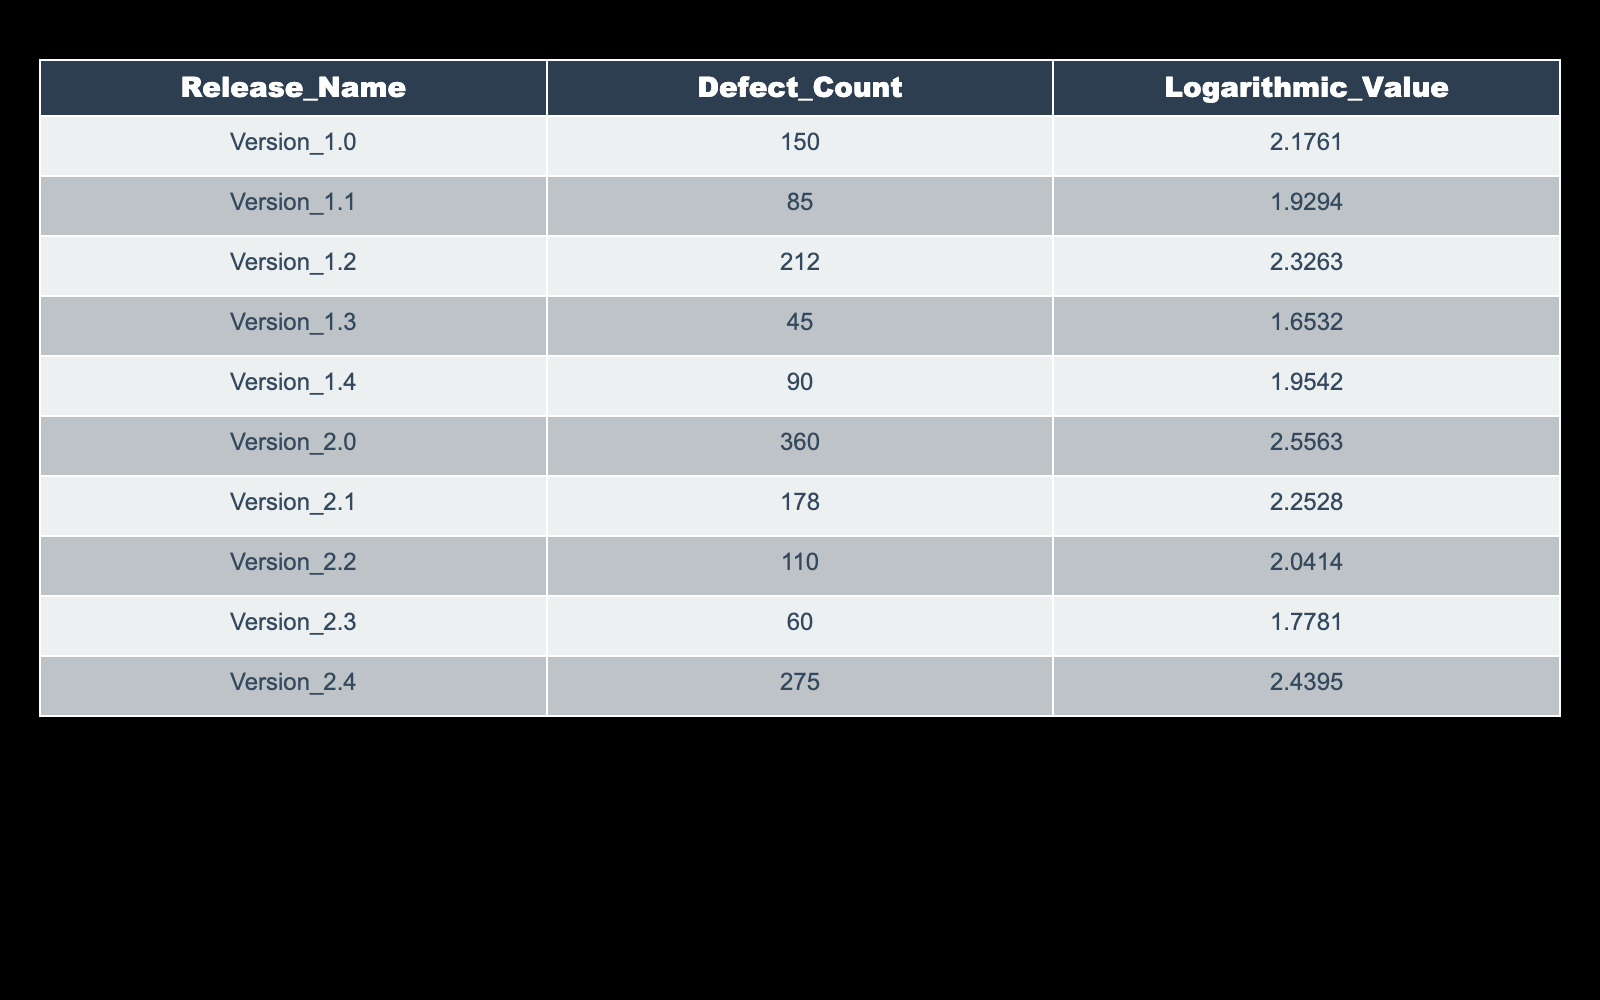What is the defect count for Version 1.1? From the table, we can look at the row corresponding to Version 1.1 and see under the Defect Count column that the value is 85.
Answer: 85 Which release has the highest logarithmic value? To find the highest logarithmic value, we compare the Logarithmic Value column and identify that Version 2.0 has the highest value of 2.5563.
Answer: Version 2.0 What is the difference in defect counts between Version 2.0 and Version 1.0? The defect count for Version 2.0 is 360, and for Version 1.0 it is 150. To find the difference, we subtract: 360 - 150 = 210.
Answer: 210 Is the defect count for Version 1.3 greater than 50? Checking the defect count for Version 1.3, which is 45, we see that 45 is not greater than 50, thus the statement is false.
Answer: No What is the average defect count for Releases 1.1, 1.2, and 1.4? We first find the defect counts for these versions: Version 1.1 has 85, Version 1.2 has 212, and Version 1.4 has 90. Now, we sum these numbers: 85 + 212 + 90 = 387. There are 3 releases, so we find the average by dividing 387 by 3, which gives us 129.
Answer: 129 Which releases have a logarithmic value greater than 2? Referring to the Logarithmic Value column, we see that Version 1.2, Version 2.0, Version 2.1, and Version 2.4 have values greater than 2.
Answer: Version 1.2, Version 2.0, Version 2.1, Version 2.4 How many releases have a defect count less than 100? We look through the Defect Count column and find that Version 1.1 (85), Version 1.3 (45), and Version 2.3 (60) have counts less than 100, totaling 3 releases.
Answer: 3 What is the sum of defect counts for all releases? Adding all defect counts together: 150 + 85 + 212 + 45 + 90 + 360 + 178 + 110 + 60 + 275 = 1,595.
Answer: 1595 Do any of the releases have a defect count that equals 60? Checking the Defect Count column, we see that Version 2.3 has a defect count of 60, making the statement true.
Answer: Yes What is the highest defect count among the releases prior to Version 2.0? We assess the defect counts for releases before Version 2.0: Version 1.0 (150), 1.1 (85), 1.2 (212), 1.3 (45), and 1.4 (90). The maximum of these is 212 from Version 1.2.
Answer: 212 